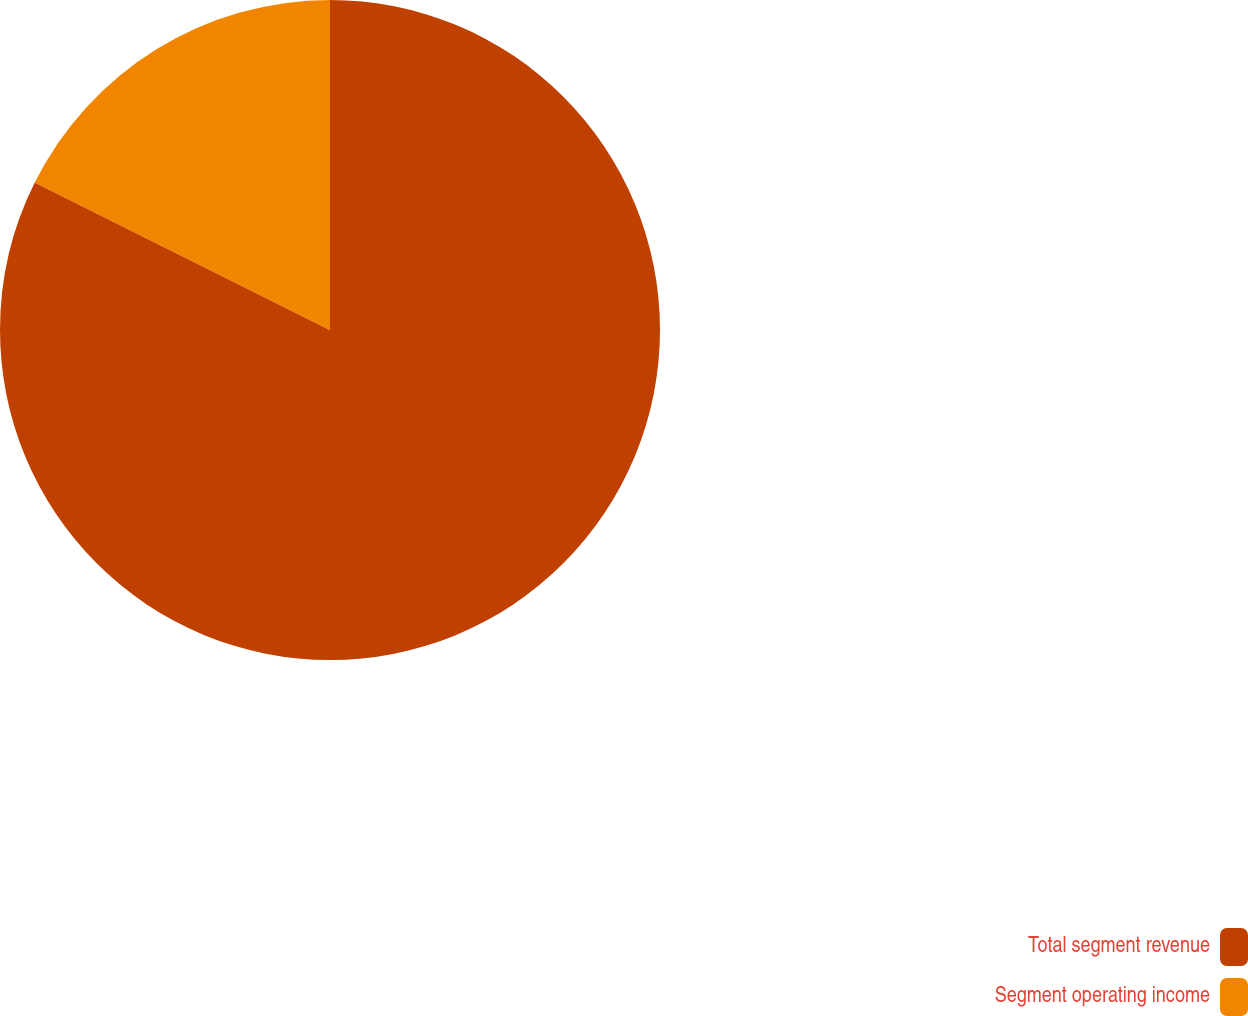<chart> <loc_0><loc_0><loc_500><loc_500><pie_chart><fcel>Total segment revenue<fcel>Segment operating income<nl><fcel>82.37%<fcel>17.63%<nl></chart> 